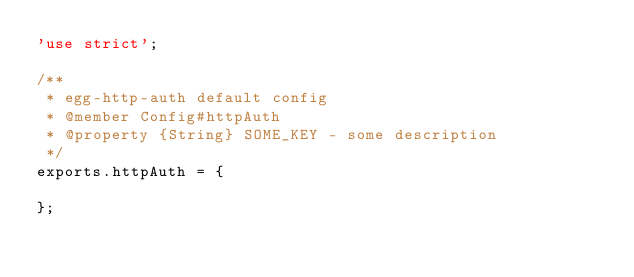<code> <loc_0><loc_0><loc_500><loc_500><_JavaScript_>'use strict';

/**
 * egg-http-auth default config
 * @member Config#httpAuth
 * @property {String} SOME_KEY - some description
 */
exports.httpAuth = {

};
</code> 